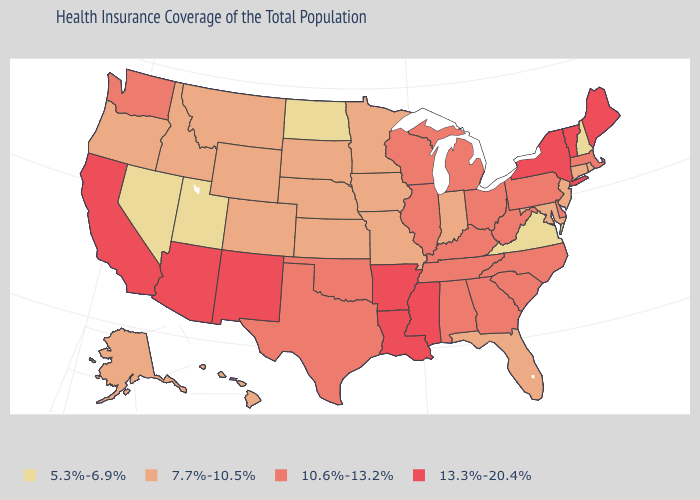Among the states that border New Hampshire , which have the highest value?
Give a very brief answer. Maine, Vermont. What is the value of Montana?
Concise answer only. 7.7%-10.5%. Among the states that border North Dakota , which have the lowest value?
Concise answer only. Minnesota, Montana, South Dakota. What is the value of Nebraska?
Be succinct. 7.7%-10.5%. What is the value of Arizona?
Answer briefly. 13.3%-20.4%. Among the states that border Pennsylvania , which have the highest value?
Answer briefly. New York. Name the states that have a value in the range 7.7%-10.5%?
Quick response, please. Alaska, Colorado, Connecticut, Florida, Hawaii, Idaho, Indiana, Iowa, Kansas, Maryland, Minnesota, Missouri, Montana, Nebraska, New Jersey, Oregon, Rhode Island, South Dakota, Wyoming. What is the highest value in states that border Wyoming?
Keep it brief. 7.7%-10.5%. What is the value of Idaho?
Answer briefly. 7.7%-10.5%. Among the states that border Minnesota , does Iowa have the highest value?
Quick response, please. No. What is the highest value in the South ?
Keep it brief. 13.3%-20.4%. Among the states that border Maryland , which have the highest value?
Be succinct. Delaware, Pennsylvania, West Virginia. What is the highest value in the South ?
Concise answer only. 13.3%-20.4%. Name the states that have a value in the range 10.6%-13.2%?
Write a very short answer. Alabama, Delaware, Georgia, Illinois, Kentucky, Massachusetts, Michigan, North Carolina, Ohio, Oklahoma, Pennsylvania, South Carolina, Tennessee, Texas, Washington, West Virginia, Wisconsin. Name the states that have a value in the range 7.7%-10.5%?
Concise answer only. Alaska, Colorado, Connecticut, Florida, Hawaii, Idaho, Indiana, Iowa, Kansas, Maryland, Minnesota, Missouri, Montana, Nebraska, New Jersey, Oregon, Rhode Island, South Dakota, Wyoming. 